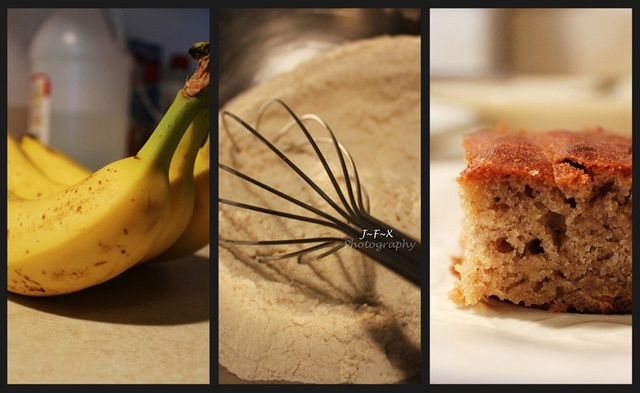Describe the objects in this image and their specific colors. I can see cake in black, brown, maroon, and tan tones, banana in black, olive, orange, and maroon tones, and bottle in black and gray tones in this image. 